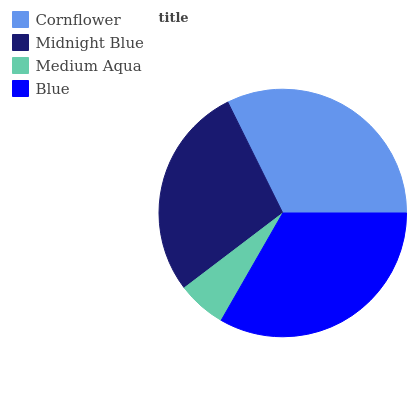Is Medium Aqua the minimum?
Answer yes or no. Yes. Is Blue the maximum?
Answer yes or no. Yes. Is Midnight Blue the minimum?
Answer yes or no. No. Is Midnight Blue the maximum?
Answer yes or no. No. Is Cornflower greater than Midnight Blue?
Answer yes or no. Yes. Is Midnight Blue less than Cornflower?
Answer yes or no. Yes. Is Midnight Blue greater than Cornflower?
Answer yes or no. No. Is Cornflower less than Midnight Blue?
Answer yes or no. No. Is Cornflower the high median?
Answer yes or no. Yes. Is Midnight Blue the low median?
Answer yes or no. Yes. Is Blue the high median?
Answer yes or no. No. Is Cornflower the low median?
Answer yes or no. No. 